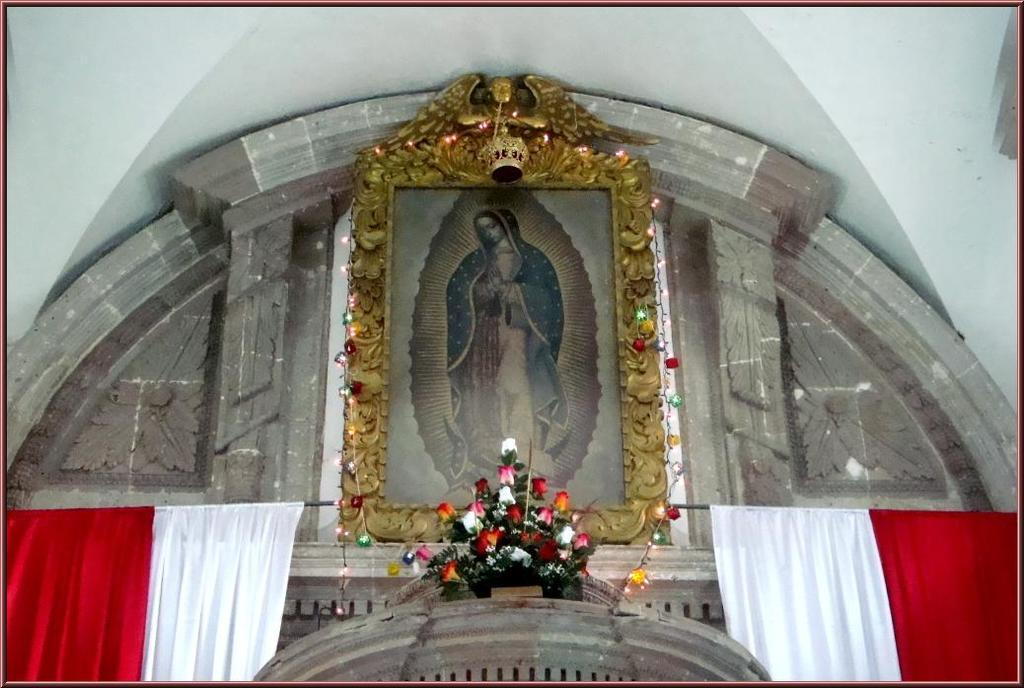What is the main object in the center of the image? There is a photo frame in the center of the image. What can be seen besides the photo frame in the image? There is a flower bouquet in the image. What type of window treatment is present on both sides of the image? There are two curtains on the right side and two curtains on the left side of the image. What is visible in the background of the image? There is a wall in the background of the image. How many girls are sitting on the floor eating food in the image? There are no girls or food present in the image; it features a photo frame, a flower bouquet, and curtains. 